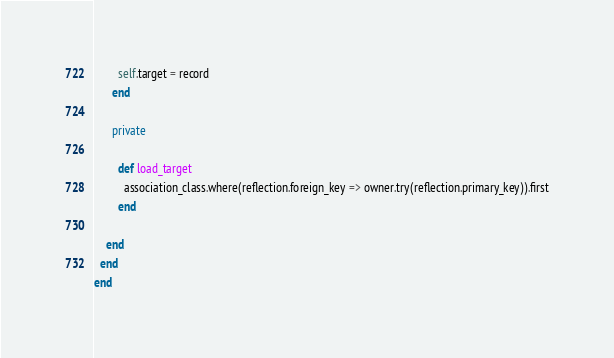Convert code to text. <code><loc_0><loc_0><loc_500><loc_500><_Ruby_>        self.target = record
      end

      private

        def load_target
          association_class.where(reflection.foreign_key => owner.try(reflection.primary_key)).first
        end

    end
  end
end</code> 